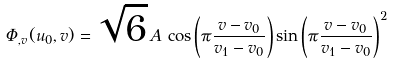Convert formula to latex. <formula><loc_0><loc_0><loc_500><loc_500>\Phi _ { , v } ( u _ { 0 } , v ) = \sqrt { 6 } \, A \, \cos \left ( \pi \frac { v - v _ { 0 } } { v _ { 1 } - v _ { 0 } } \right ) \sin \left ( \pi \frac { v - v _ { 0 } } { v _ { 1 } - v _ { 0 } } \right ) ^ { 2 }</formula> 